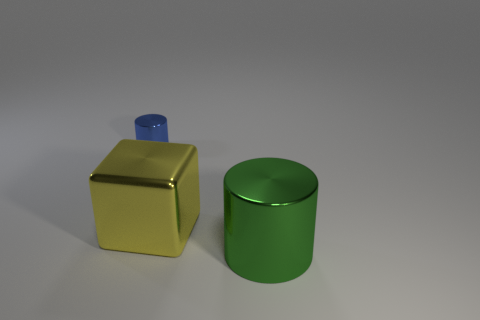What number of other things are there of the same size as the metallic cube?
Provide a succinct answer. 1. What is the thing that is both behind the big metallic cylinder and in front of the blue cylinder made of?
Ensure brevity in your answer.  Metal. Does the big object that is left of the large cylinder have the same shape as the thing that is to the left of the yellow shiny block?
Make the answer very short. No. Is there anything else that has the same material as the block?
Give a very brief answer. Yes. What is the shape of the blue thing left of the shiny object that is to the right of the big object to the left of the large green shiny thing?
Your response must be concise. Cylinder. What number of other objects are the same shape as the tiny thing?
Provide a short and direct response. 1. The metallic thing that is the same size as the cube is what color?
Your response must be concise. Green. How many cylinders are big rubber objects or small blue metal things?
Provide a short and direct response. 1. What number of matte things are there?
Offer a terse response. 0. Do the big green shiny thing and the large object on the left side of the large metallic cylinder have the same shape?
Your answer should be compact. No. 